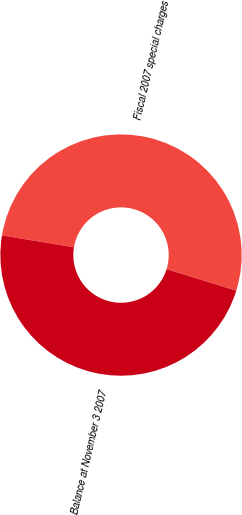Convert chart to OTSL. <chart><loc_0><loc_0><loc_500><loc_500><pie_chart><fcel>Fiscal 2007 special charges<fcel>Balance at November 3 2007<nl><fcel>52.17%<fcel>47.83%<nl></chart> 